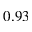<formula> <loc_0><loc_0><loc_500><loc_500>0 . 9 3</formula> 